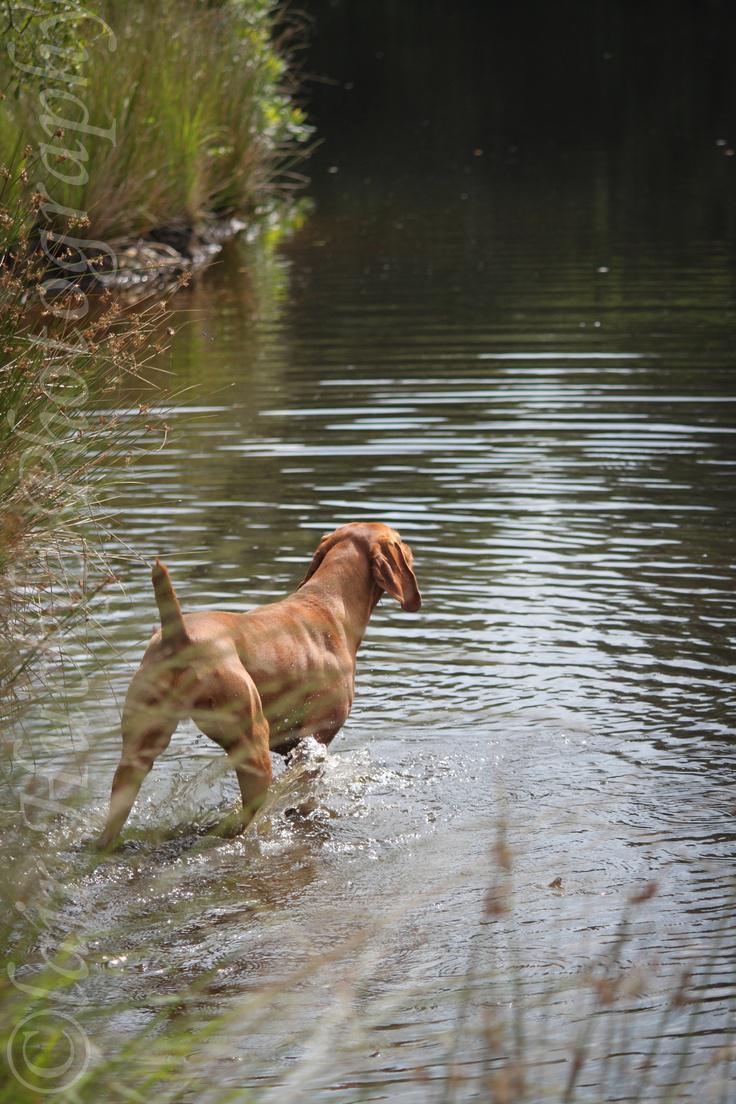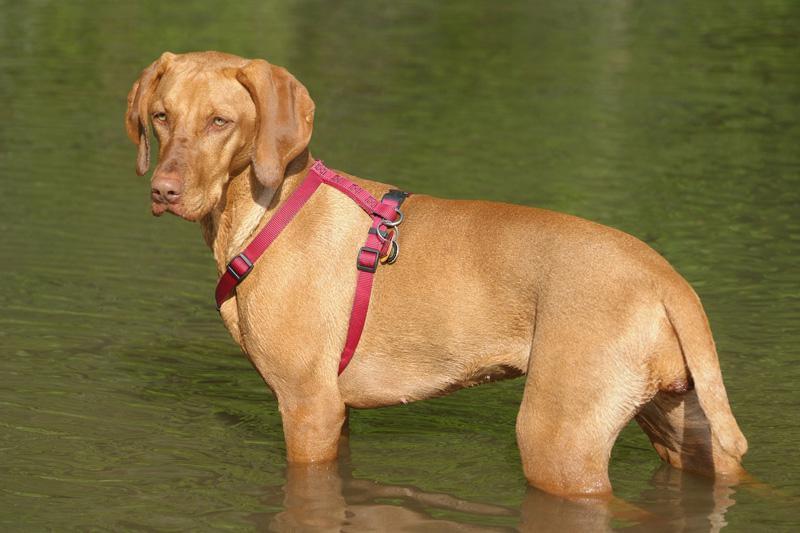The first image is the image on the left, the second image is the image on the right. Examine the images to the left and right. Is the description "In one image a dog is standing with one front leg raised up and its tail extended behind it." accurate? Answer yes or no. No. The first image is the image on the left, the second image is the image on the right. Considering the images on both sides, is "One image shows a red-orange dog standing in profile with its head upright, tail outstretched, and a front paw raised and bent inward." valid? Answer yes or no. No. 